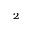Convert formula to latex. <formula><loc_0><loc_0><loc_500><loc_500>_ { 2 }</formula> 